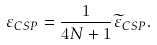<formula> <loc_0><loc_0><loc_500><loc_500>\varepsilon _ { C S P } = \frac { 1 } { 4 N + 1 } \widetilde { \varepsilon } _ { C S P } .</formula> 